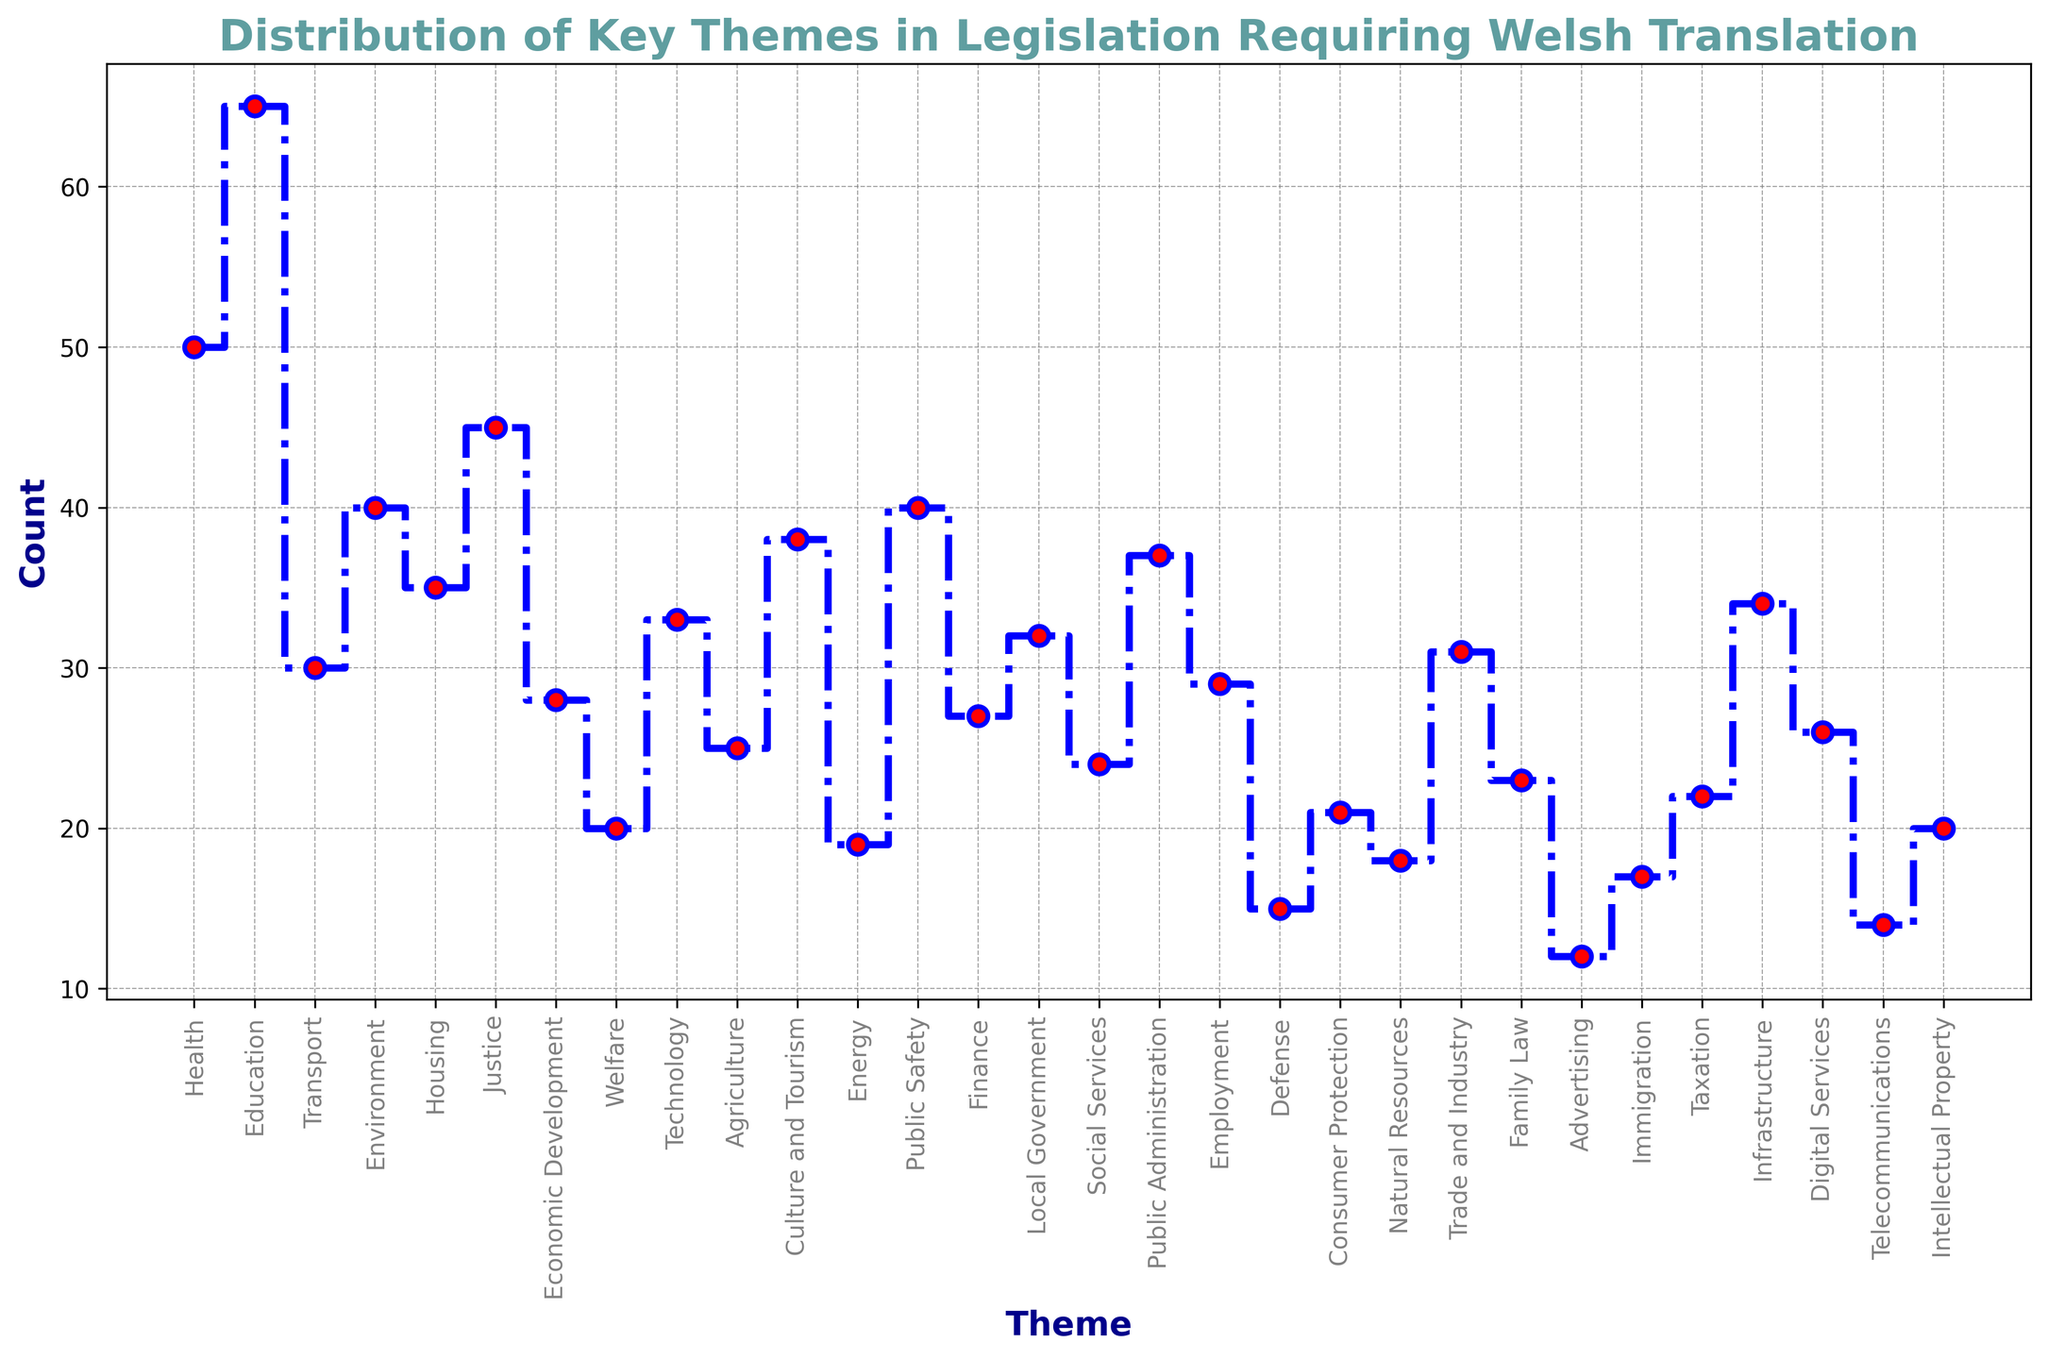Which theme has the highest count? Observe the height of the steps on the plot. The theme with the highest step is Education.
Answer: Education Which theme has the lowest count? Observe the height of the steps on the plot. The theme with the lowest step is Defense.
Answer: Defense How much higher is the count for Health compared to Trade and Industry? Find the count for Health (50) and for Trade and Industry (31). Subtract 31 from 50.
Answer: 19 What is the average count of the themes Justice, Technology, and Public Safety? Add the counts of Justice (45), Technology (33), and Public Safety (40). Then divide by 3. The average is (45 + 33 + 40) / 3 = 39.33.
Answer: 39.33 Which themes have counts greater than 40? Check the plot for the themes with steps higher than 40. The themes are Health, Education, and Justice.
Answer: Health, Education, Justice What is the combined count for Environment and Housing themes? Add the counts for Environment (40) and Housing (35). The combined count is 40 + 35 = 75.
Answer: 75 How many themes have a count of less than 20? Look for themes with steps below the height corresponding to 20 counts. The themes are Energy (19), Defense (15), Natural Resources (18), Telecommunications (14), Immigration (17), and Advertising (12). There are 6 such themes.
Answer: 6 Which theme has a count closest to the median count of all themes? First, list the counts in ascending order: 12, 14, 15, 17, 18, 19, 20, 20, 21, 22, 23, 24, 25, 26, 27, 28, 29, 30, 31, 32, 33, 34, 35, 37, 38, 40, 40, 45, 50, 65. The median is the average of the 15th and 16th values (26, 27), which is 26.5. The theme closest to this median count is Digital Services with a count of 26.
Answer: Digital Services What is the difference in count between the Education and Welfare themes? Find the counts for Education (65) and Welfare (20). Subtract 20 from 65.
Answer: 45 What is the average count for topics related to public services: Health, Education, and Public Safety? Add the counts for Health (50), Education (65), and Public Safety (40). Then divide by 3. The average is (50 + 65 + 40) / 3 = 51.67.
Answer: 51.67 